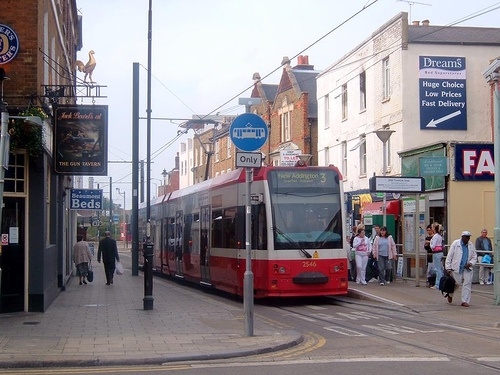Describe the objects in this image and their specific colors. I can see train in maroon, gray, black, and darkgray tones, bus in maroon, gray, black, and darkgray tones, people in maroon, darkgray, gray, and black tones, people in maroon, black, darkgray, and gray tones, and people in maroon, gray, and black tones in this image. 